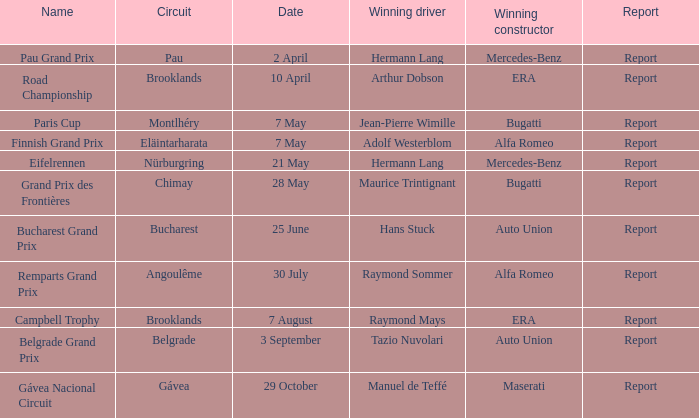Tell me the winning constructor for the paris cup Bugatti. 